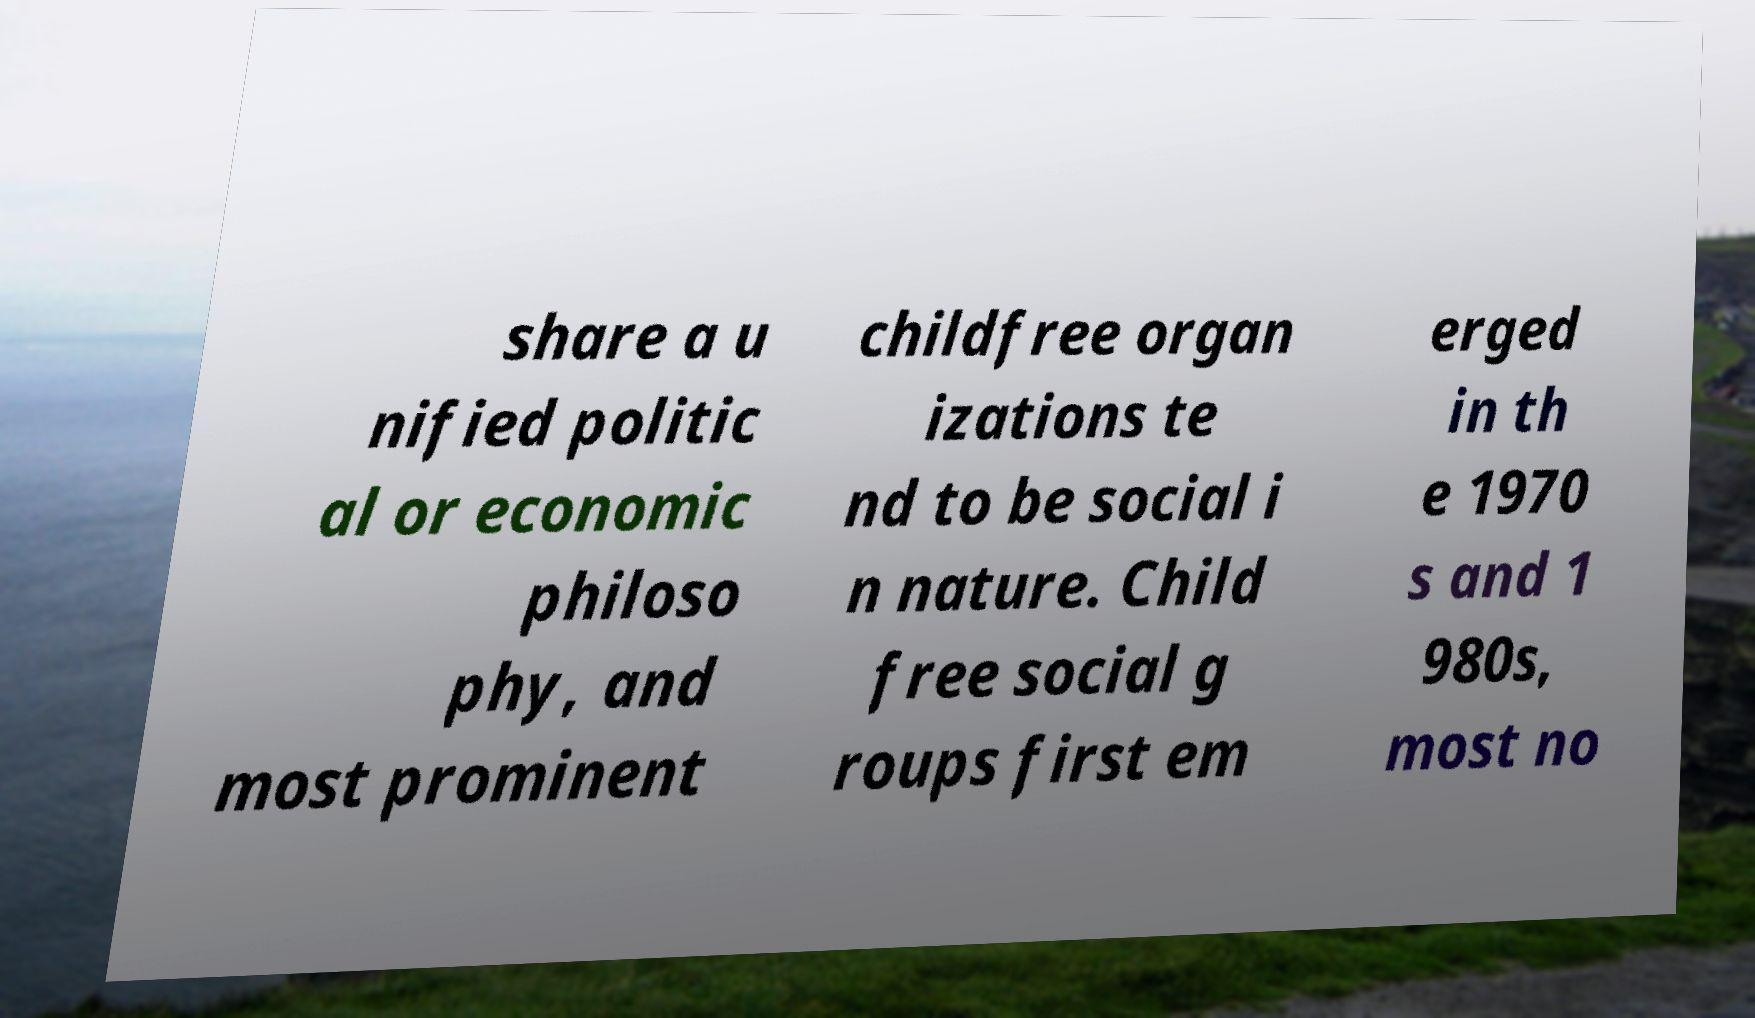Can you read and provide the text displayed in the image?This photo seems to have some interesting text. Can you extract and type it out for me? share a u nified politic al or economic philoso phy, and most prominent childfree organ izations te nd to be social i n nature. Child free social g roups first em erged in th e 1970 s and 1 980s, most no 